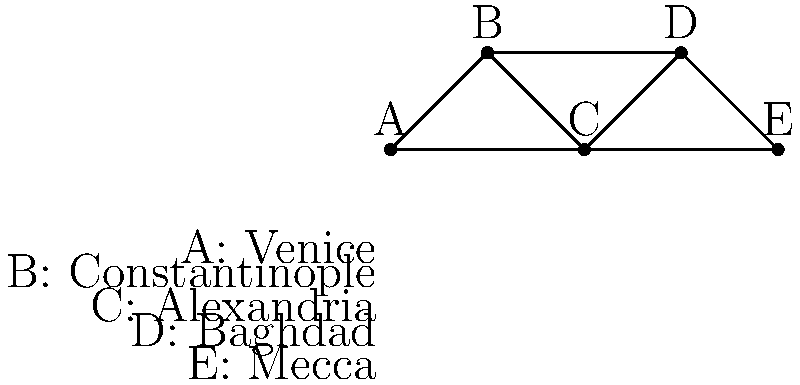In this medieval trade network, which city acts as the most crucial hub, connecting the most other cities directly? How many direct connections does this city have? To determine the most crucial hub in this medieval trade network, we need to count the number of direct connections (edges) for each city (vertex). Let's analyze each city:

1. Venice (A):
   - Connected to Constantinople (B) and Alexandria (C)
   - Total connections: 2

2. Constantinople (B):
   - Connected to Venice (A), Alexandria (C), and Baghdad (D)
   - Total connections: 3

3. Alexandria (C):
   - Connected to Venice (A), Constantinople (B), Baghdad (D), and Mecca (E)
   - Total connections: 4

4. Baghdad (D):
   - Connected to Constantinople (B), Alexandria (C), and Mecca (E)
   - Total connections: 3

5. Mecca (E):
   - Connected to Alexandria (C) and Baghdad (D)
   - Total connections: 2

From this analysis, we can see that Alexandria (C) has the most direct connections with 4 edges, making it the most crucial hub in this network.
Answer: Alexandria, 4 connections 